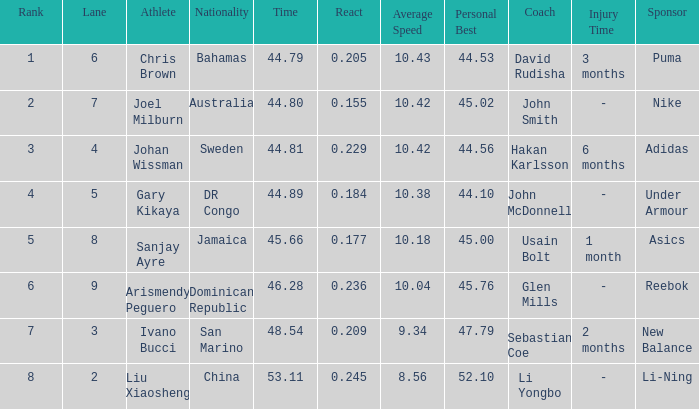What is the total average for Rank entries where the Lane listed is smaller than 4 and the Nationality listed is San Marino? 7.0. 